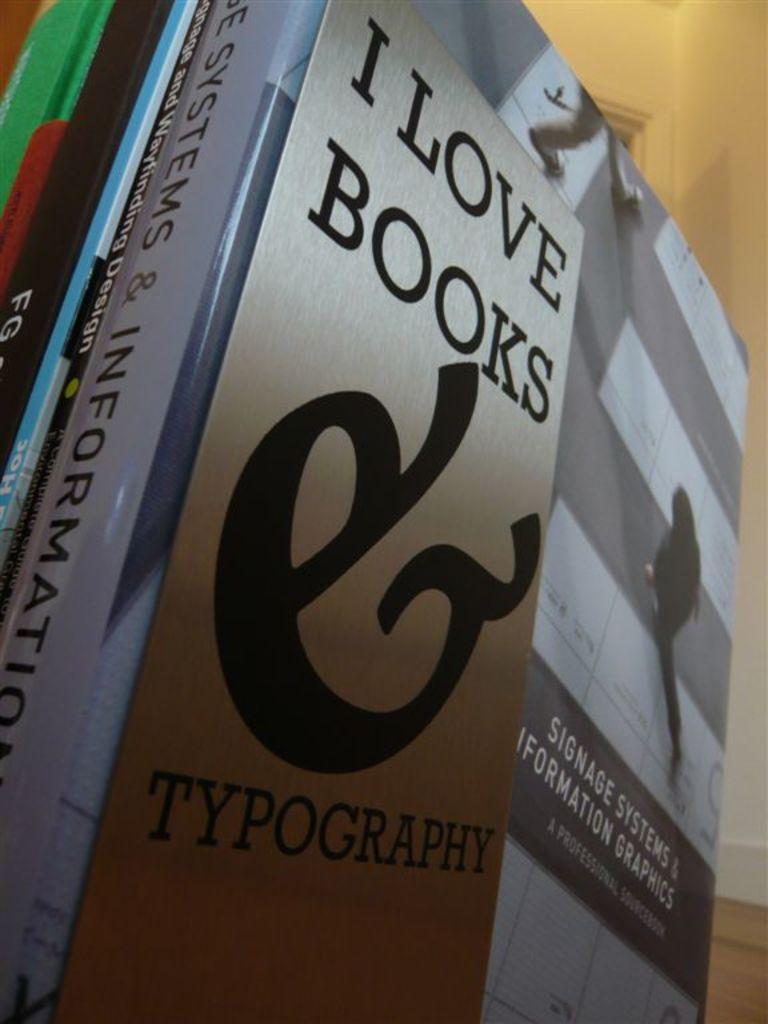Who loves books?
Keep it short and to the point. I. What type of book is this?
Your response must be concise. Typography. 